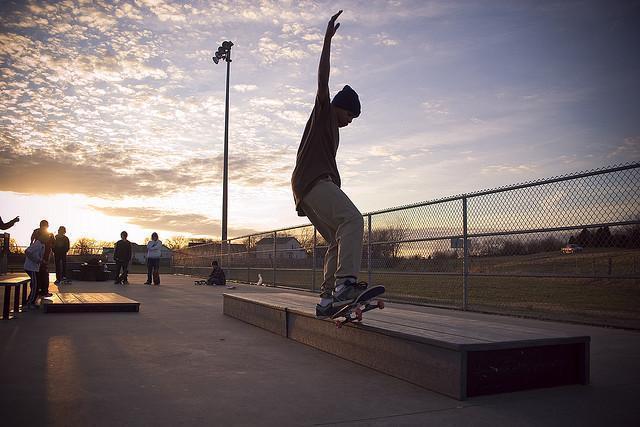How many brown horses are there?
Give a very brief answer. 0. 